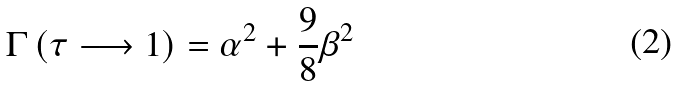<formula> <loc_0><loc_0><loc_500><loc_500>\Gamma \left ( \tau \longrightarrow 1 \right ) = \alpha ^ { 2 } + \frac { 9 } { 8 } \beta ^ { 2 }</formula> 